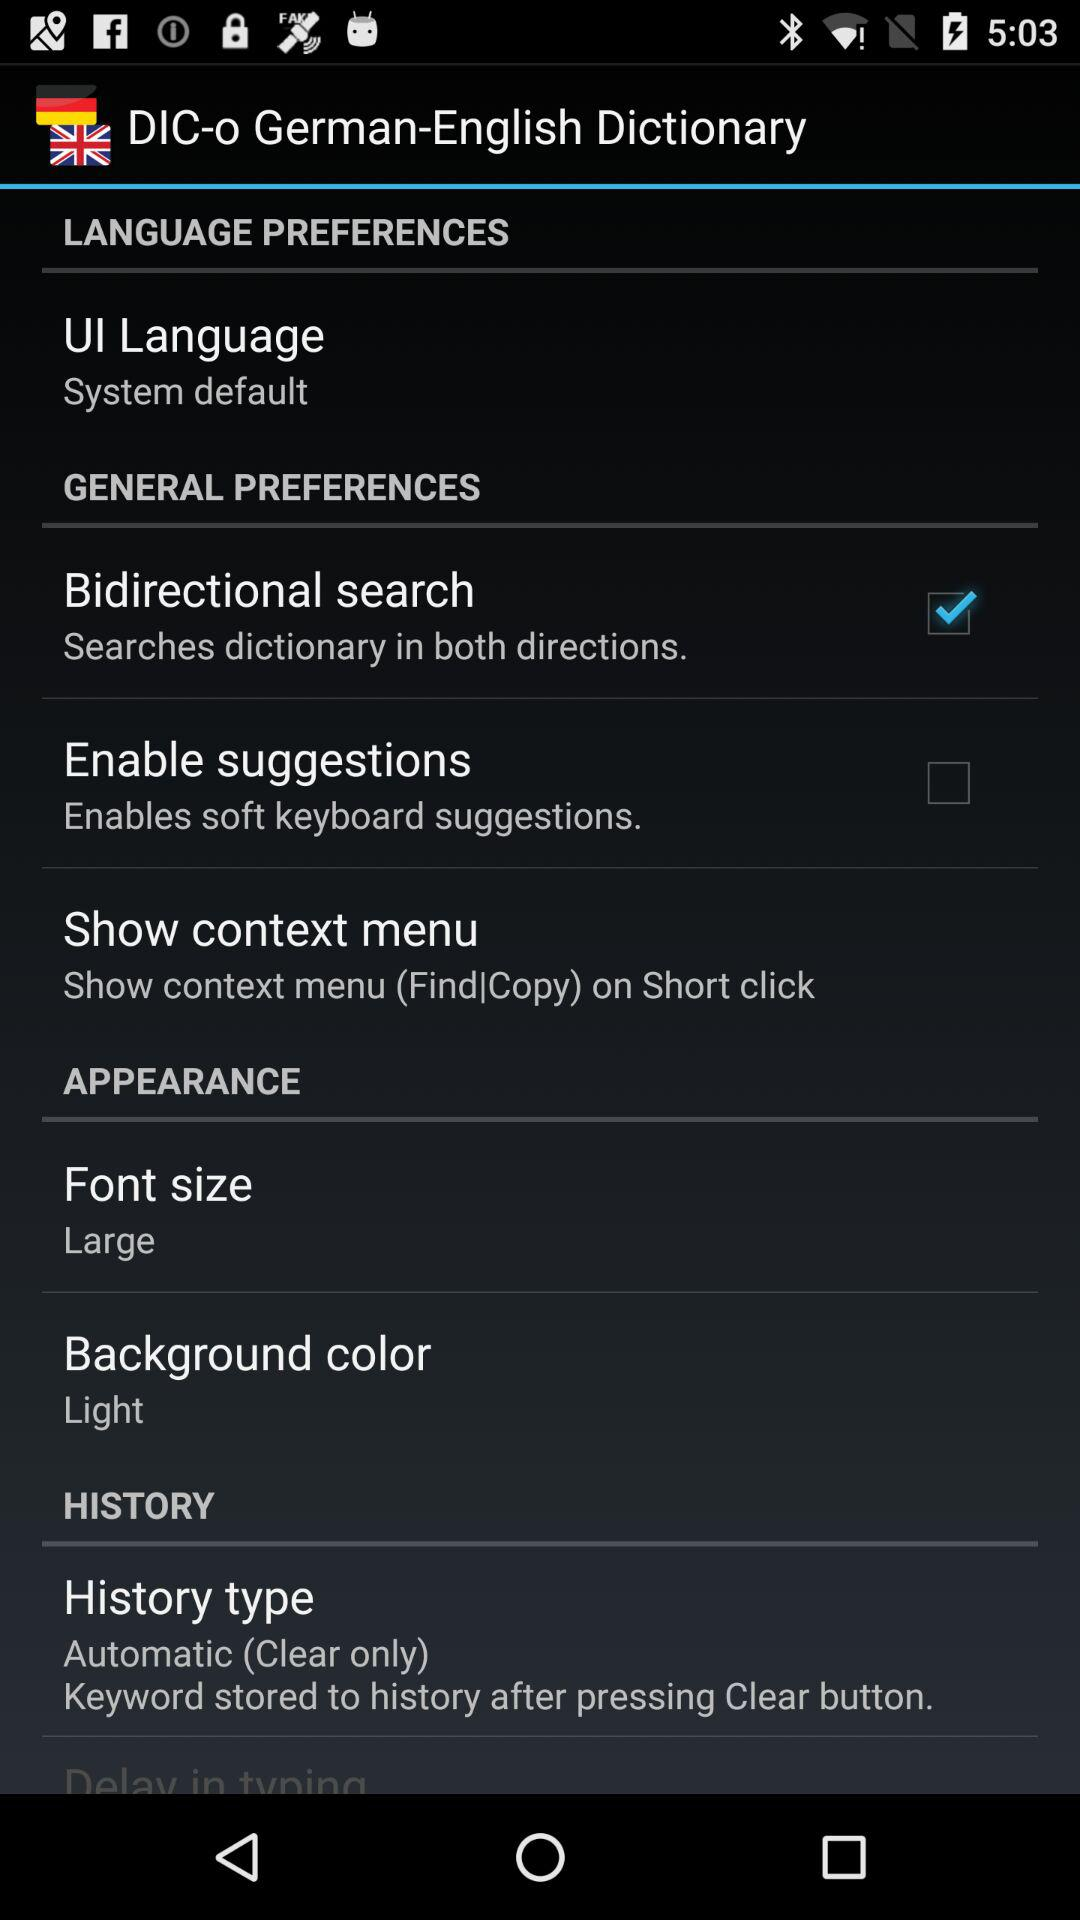What is the font size? The font size is large. 